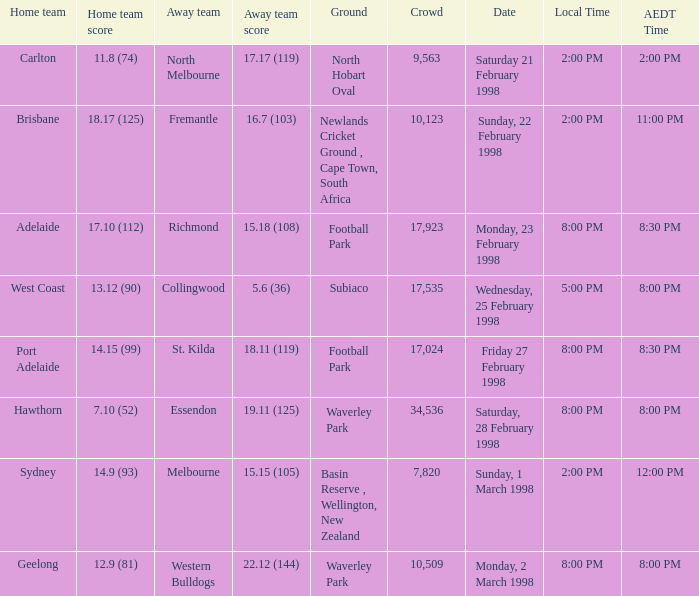Determine the aedt time corresponding to a local time of 8:00 pm and an away team score of 22.12 (144). 8:00 PM. 